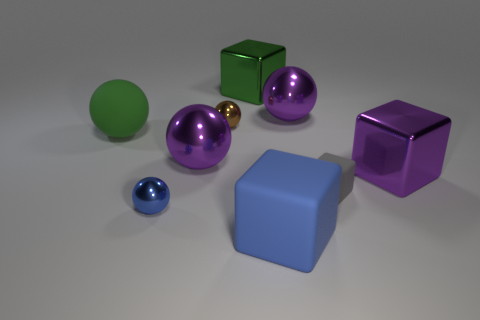How many large green things are behind the purple metal object behind the green ball?
Provide a short and direct response. 1. Are there any small blue metallic spheres that are behind the large shiny sphere that is to the left of the big rubber thing in front of the big purple metallic block?
Your response must be concise. No. There is a gray object that is the same shape as the large blue thing; what material is it?
Provide a short and direct response. Rubber. Is there anything else that is made of the same material as the gray block?
Your answer should be compact. Yes. Is the brown ball made of the same material as the sphere in front of the tiny cube?
Provide a short and direct response. Yes. What shape is the tiny shiny thing that is in front of the matte sphere that is left of the tiny gray matte cube?
Your answer should be compact. Sphere. How many large things are blue matte cubes or cyan blocks?
Your answer should be very brief. 1. How many big green things have the same shape as the big blue object?
Offer a very short reply. 1. There is a big blue thing; is its shape the same as the big rubber thing on the left side of the blue block?
Provide a succinct answer. No. There is a tiny matte thing; what number of big blocks are behind it?
Keep it short and to the point. 2. 